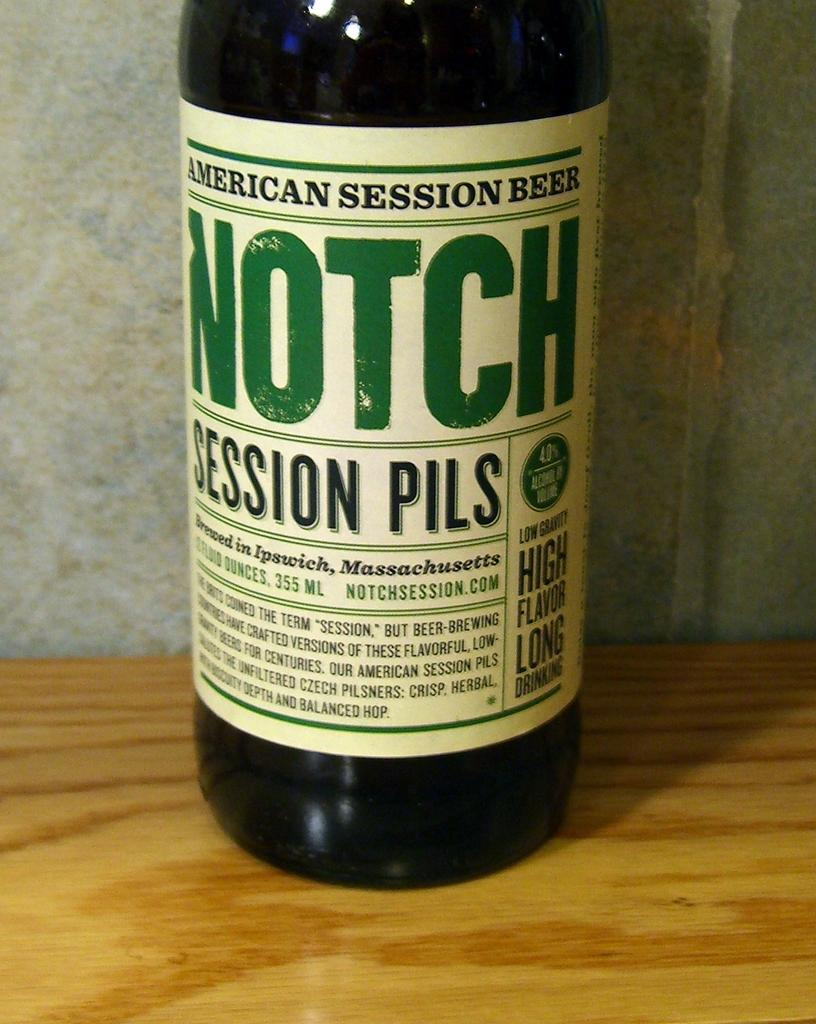<image>
Create a compact narrative representing the image presented. A bottom of American Session Beer sits on a wooden table 